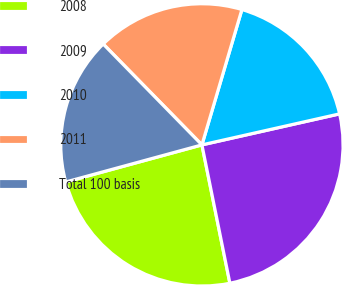<chart> <loc_0><loc_0><loc_500><loc_500><pie_chart><fcel>2008<fcel>2009<fcel>2010<fcel>2011<fcel>Total 100 basis<nl><fcel>23.94%<fcel>25.35%<fcel>16.9%<fcel>16.9%<fcel>16.9%<nl></chart> 